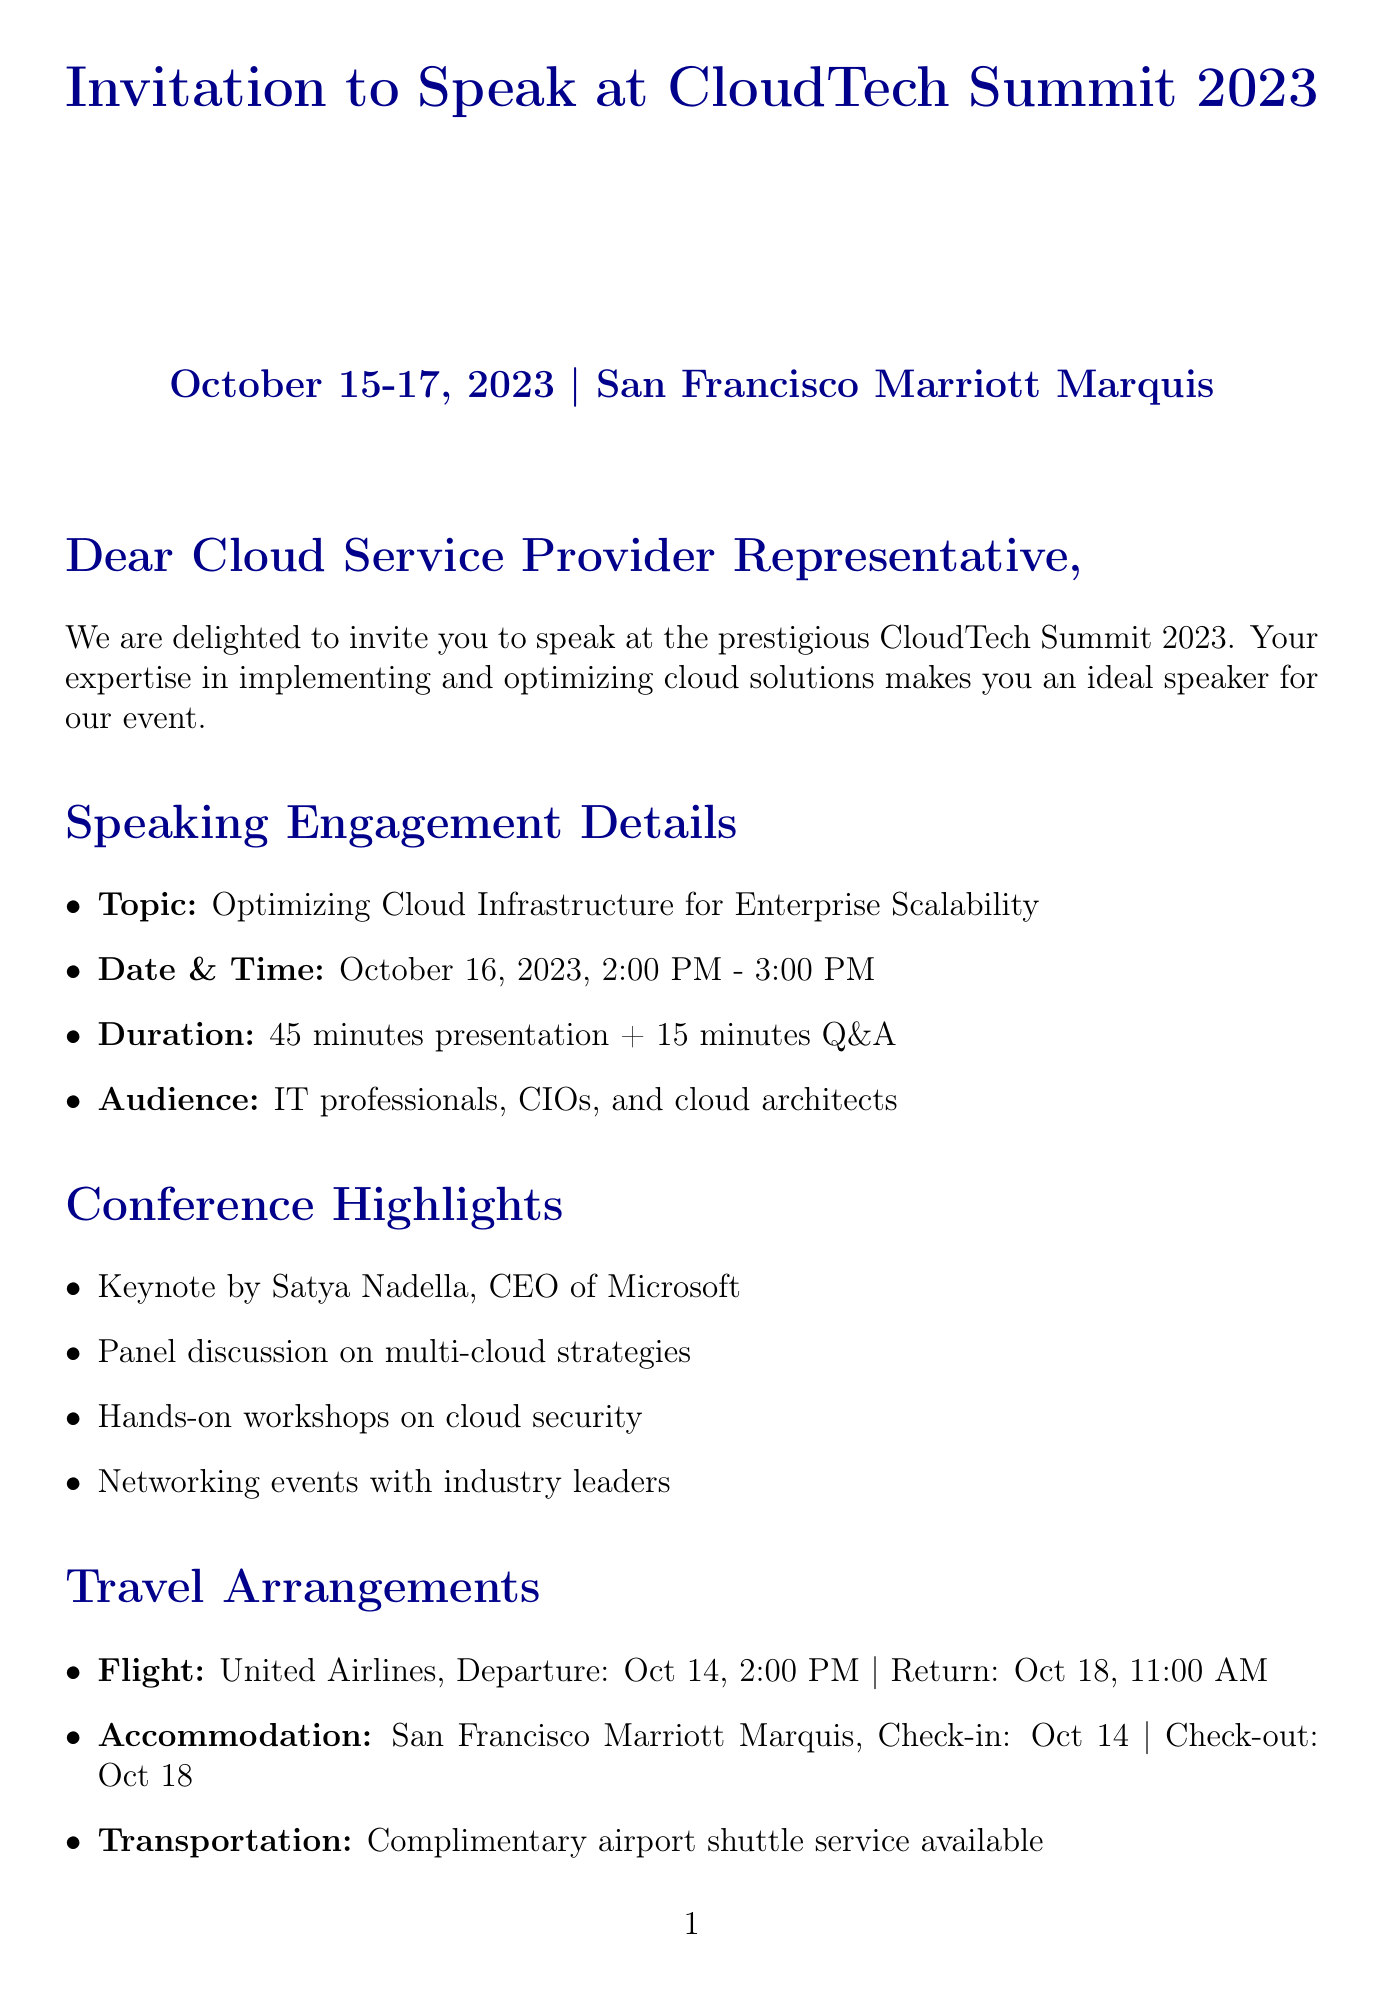What is the event name? The event name is explicitly mentioned in the document as part of the title.
Answer: CloudTech Summit 2023 What are the dates of the conference? The dates are provided clearly in the introductory section of the document.
Answer: October 15-17, 2023 Who is the keynote speaker? The name of the keynote speaker is listed under the conference highlights.
Answer: Satya Nadella When is the speaking slot scheduled? The specific date and time for the speaking engagement are noted in the speaking engagement details.
Answer: October 16, 2023, 2:00 PM - 3:00 PM What is the duration of the presentation? The duration for the speaking engagement is mentioned clearly in the document.
Answer: 45 minutes presentation + 15 minutes Q&A What airline is being used for the travel arrangements? The airline name for the flight is mentioned in the travel arrangements section.
Answer: United Airlines What type of audience will be present at the session? The audience type is specified in the speaking engagement details section.
Answer: IT professionals, CIOs, and cloud architects What benefits do speakers receive? The benefits offered to speakers are listed in the speaker benefits section.
Answer: Complimentary conference pass What hotel will the speaker be staying at? The name of the accommodation is provided in the travel arrangements section.
Answer: San Francisco Marriott Marquis 